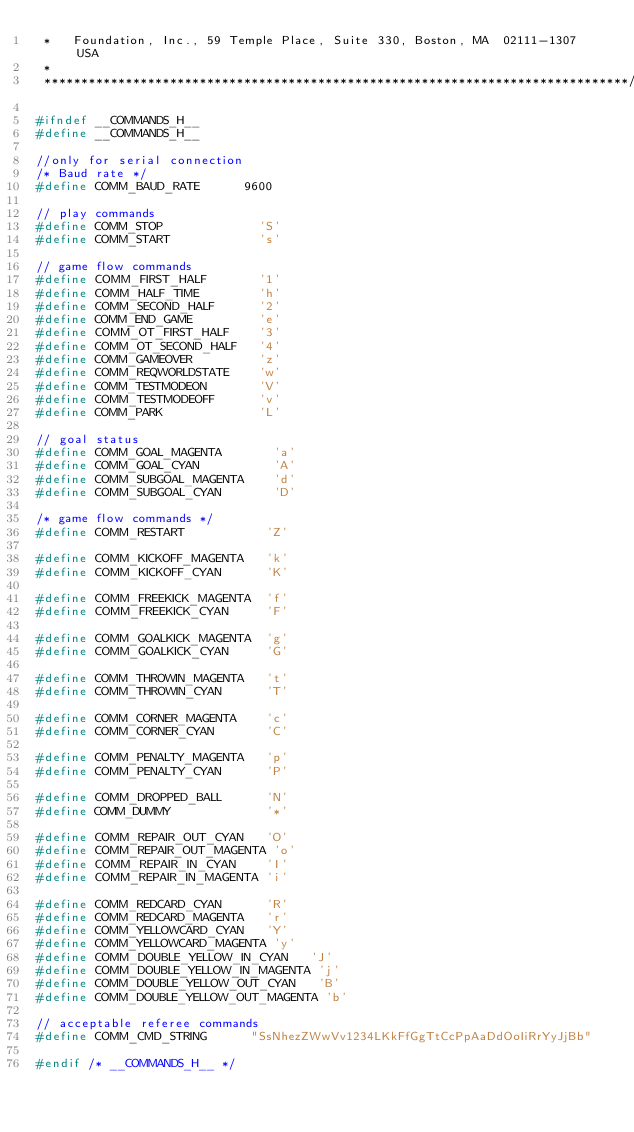<code> <loc_0><loc_0><loc_500><loc_500><_C_> *   Foundation, Inc., 59 Temple Place, Suite 330, Boston, MA  02111-1307  USA
 *
 *******************************************************************************/

#ifndef __COMMANDS_H__
#define __COMMANDS_H__

//only for serial connection
/* Baud rate */
#define COMM_BAUD_RATE      9600

// play commands
#define COMM_STOP             'S'
#define COMM_START            's'

// game flow commands
#define COMM_FIRST_HALF       '1'
#define COMM_HALF_TIME        'h'
#define COMM_SECOND_HALF      '2'
#define COMM_END_GAME         'e'
#define COMM_OT_FIRST_HALF    '3'
#define COMM_OT_SECOND_HALF   '4'
#define COMM_GAMEOVER         'z'
#define COMM_REQWORLDSTATE    'w'
#define COMM_TESTMODEON       'V'
#define COMM_TESTMODEOFF      'v'
#define COMM_PARK             'L'

// goal status
#define COMM_GOAL_MAGENTA       'a'
#define COMM_GOAL_CYAN          'A'
#define COMM_SUBGOAL_MAGENTA    'd'
#define COMM_SUBGOAL_CYAN       'D'

/* game flow commands */
#define COMM_RESTART           'Z'

#define COMM_KICKOFF_MAGENTA   'k'
#define COMM_KICKOFF_CYAN      'K'

#define COMM_FREEKICK_MAGENTA  'f'
#define COMM_FREEKICK_CYAN     'F'

#define COMM_GOALKICK_MAGENTA  'g'
#define COMM_GOALKICK_CYAN     'G'

#define COMM_THROWIN_MAGENTA   't'
#define COMM_THROWIN_CYAN      'T'

#define COMM_CORNER_MAGENTA    'c'
#define COMM_CORNER_CYAN       'C'

#define COMM_PENALTY_MAGENTA   'p'
#define COMM_PENALTY_CYAN      'P'

#define COMM_DROPPED_BALL      'N'
#define COMM_DUMMY             '*'

#define COMM_REPAIR_OUT_CYAN   'O'
#define COMM_REPAIR_OUT_MAGENTA 'o'
#define COMM_REPAIR_IN_CYAN    'I'
#define COMM_REPAIR_IN_MAGENTA 'i'

#define COMM_REDCARD_CYAN      'R'
#define COMM_REDCARD_MAGENTA   'r'
#define COMM_YELLOWCARD_CYAN   'Y'
#define COMM_YELLOWCARD_MAGENTA 'y'
#define COMM_DOUBLE_YELLOW_IN_CYAN   'J'
#define COMM_DOUBLE_YELLOW_IN_MAGENTA 'j'
#define COMM_DOUBLE_YELLOW_OUT_CYAN   'B'
#define COMM_DOUBLE_YELLOW_OUT_MAGENTA 'b'

// acceptable referee commands
#define COMM_CMD_STRING      "SsNhezZWwVv1234LKkFfGgTtCcPpAaDdOoIiRrYyJjBb"

#endif /* __COMMANDS_H__ */
</code> 